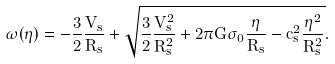Convert formula to latex. <formula><loc_0><loc_0><loc_500><loc_500>\omega ( \eta ) = - \frac { 3 } { 2 } \frac { V _ { s } } { R _ { s } } + \sqrt { \frac { 3 } { 2 } \frac { V _ { s } ^ { 2 } } { R _ { s } ^ { 2 } } + 2 \pi G \sigma _ { 0 } \frac { \eta } { R _ { s } } - c _ { s } ^ { 2 } \frac { \eta ^ { 2 } } { R _ { s } ^ { 2 } } } .</formula> 